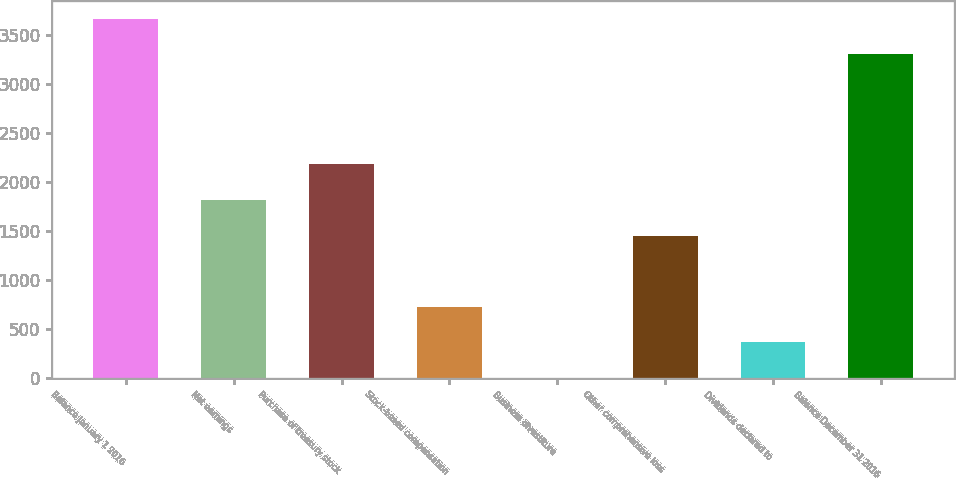Convert chart to OTSL. <chart><loc_0><loc_0><loc_500><loc_500><bar_chart><fcel>Balance January 1 2016<fcel>Net earnings<fcel>Purchase of treasury stock<fcel>Stock-based compensation<fcel>Business divestiture<fcel>Other comprehensive loss<fcel>Dividends declared to<fcel>Balance December 31 2016<nl><fcel>3664.57<fcel>1818.15<fcel>2180.82<fcel>730.14<fcel>4.8<fcel>1455.48<fcel>367.47<fcel>3301.9<nl></chart> 